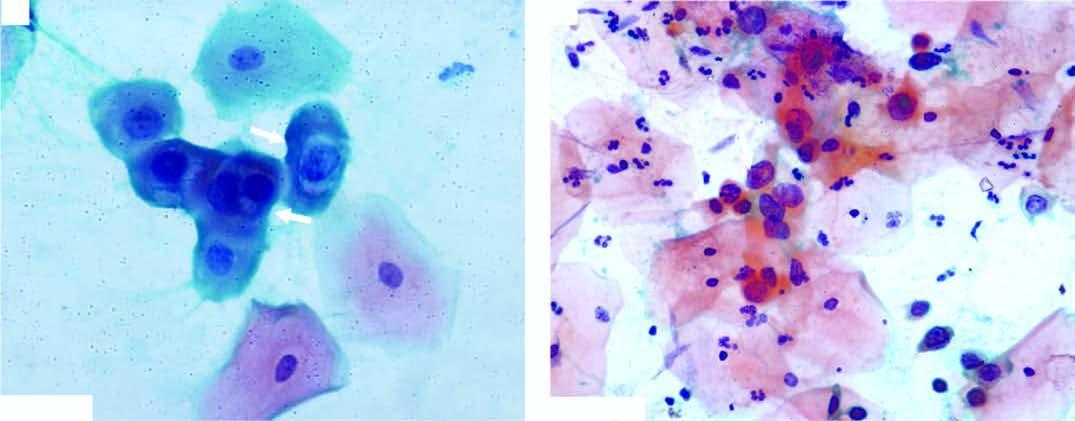did scanty cytoplasm and markedly hyperchromatic nuclei have irregular nuclear outlines?
Answer the question using a single word or phrase. Yes 